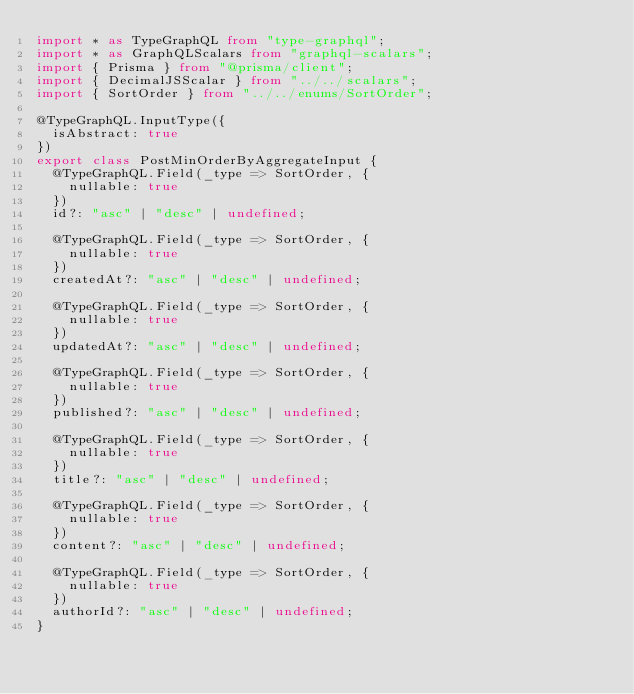<code> <loc_0><loc_0><loc_500><loc_500><_TypeScript_>import * as TypeGraphQL from "type-graphql";
import * as GraphQLScalars from "graphql-scalars";
import { Prisma } from "@prisma/client";
import { DecimalJSScalar } from "../../scalars";
import { SortOrder } from "../../enums/SortOrder";

@TypeGraphQL.InputType({
  isAbstract: true
})
export class PostMinOrderByAggregateInput {
  @TypeGraphQL.Field(_type => SortOrder, {
    nullable: true
  })
  id?: "asc" | "desc" | undefined;

  @TypeGraphQL.Field(_type => SortOrder, {
    nullable: true
  })
  createdAt?: "asc" | "desc" | undefined;

  @TypeGraphQL.Field(_type => SortOrder, {
    nullable: true
  })
  updatedAt?: "asc" | "desc" | undefined;

  @TypeGraphQL.Field(_type => SortOrder, {
    nullable: true
  })
  published?: "asc" | "desc" | undefined;

  @TypeGraphQL.Field(_type => SortOrder, {
    nullable: true
  })
  title?: "asc" | "desc" | undefined;

  @TypeGraphQL.Field(_type => SortOrder, {
    nullable: true
  })
  content?: "asc" | "desc" | undefined;

  @TypeGraphQL.Field(_type => SortOrder, {
    nullable: true
  })
  authorId?: "asc" | "desc" | undefined;
}
</code> 